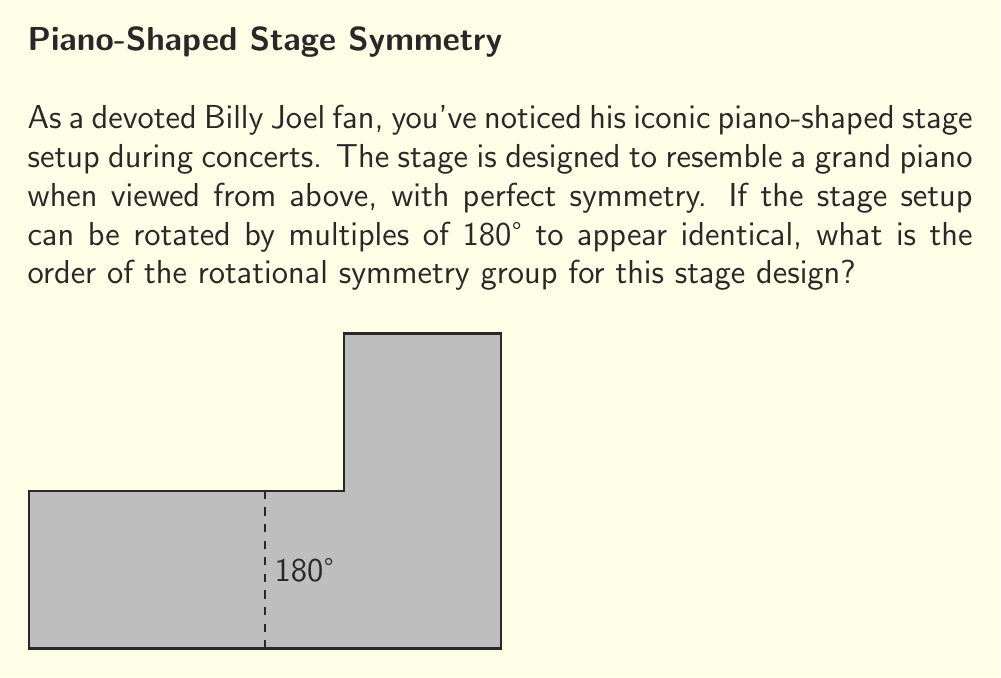Can you answer this question? To determine the order of the rotational symmetry group for Billy Joel's piano-shaped stage, let's follow these steps:

1) First, we need to understand what rotational symmetry means. A shape has rotational symmetry if it can be rotated about its center by a certain angle and still look the same.

2) In this case, the stage looks like a grand piano from above. It has two positions where it looks identical:
   a) Its original position (0° rotation)
   b) After a 180° rotation

3) We can represent these rotations as elements of a group:
   - Let $e$ represent the identity (0° rotation)
   - Let $r$ represent the 180° rotation

4) The group operation is composition of rotations. We can see that:
   $$e \circ e = e$$
   $$e \circ r = r \circ e = r$$
   $$r \circ r = e$$

5) This forms a cyclic group of order 2, often denoted as $C_2$ or $\mathbb{Z}_2$.

6) The order of a group is the number of elements in the group. In this case, there are two elements: $e$ and $r$.

Therefore, the order of the rotational symmetry group for Billy Joel's piano-shaped stage is 2.
Answer: 2 